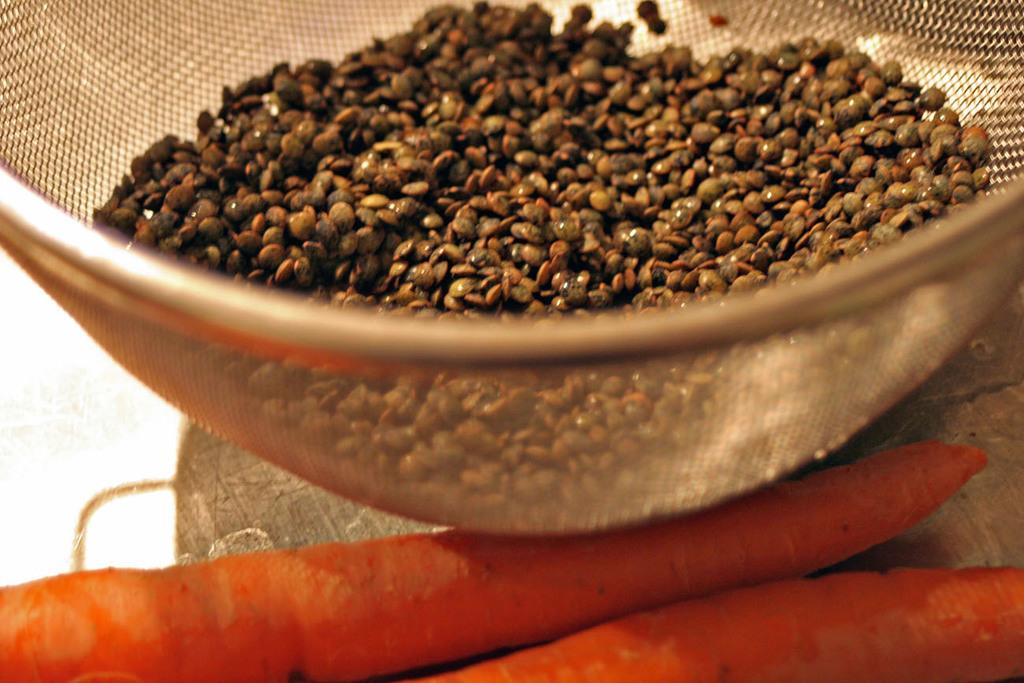What is hanging at the top of the image? There are seeds placed in a net at the top of the image. What is the net hanging from? The net is placed on a wooden object. What vegetables can be seen on the wooden object? There are two carrots on the wooden object. What color is the background of the image? The background of the image is white in color. How do the seeds affect the pet in the image? There is no pet present in the image, so the seeds cannot have any effect on a pet. Who are the friends of the carrots in the image? The concept of friends does not apply to vegetables like carrots, so there are no friends for the carrots in the image. 